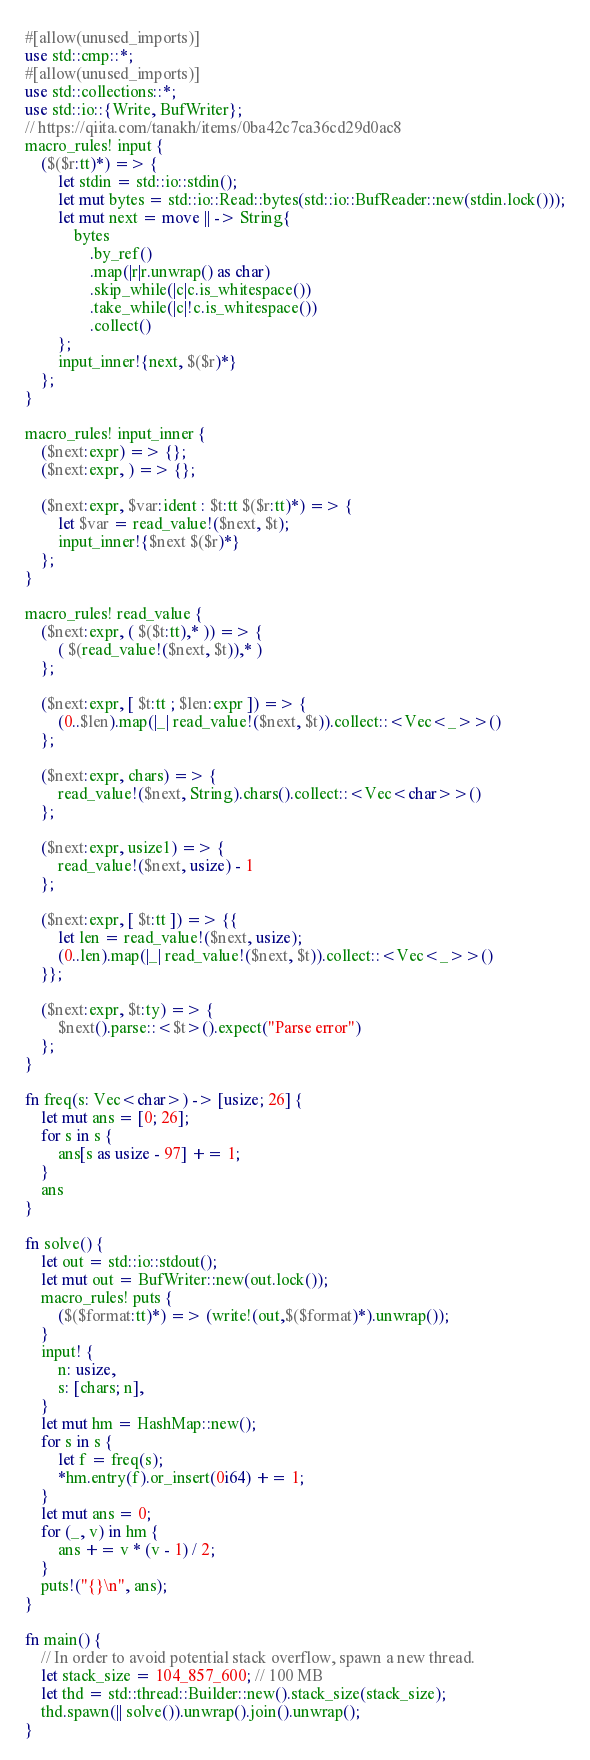Convert code to text. <code><loc_0><loc_0><loc_500><loc_500><_Rust_>#[allow(unused_imports)]
use std::cmp::*;
#[allow(unused_imports)]
use std::collections::*;
use std::io::{Write, BufWriter};
// https://qiita.com/tanakh/items/0ba42c7ca36cd29d0ac8
macro_rules! input {
    ($($r:tt)*) => {
        let stdin = std::io::stdin();
        let mut bytes = std::io::Read::bytes(std::io::BufReader::new(stdin.lock()));
        let mut next = move || -> String{
            bytes
                .by_ref()
                .map(|r|r.unwrap() as char)
                .skip_while(|c|c.is_whitespace())
                .take_while(|c|!c.is_whitespace())
                .collect()
        };
        input_inner!{next, $($r)*}
    };
}

macro_rules! input_inner {
    ($next:expr) => {};
    ($next:expr, ) => {};

    ($next:expr, $var:ident : $t:tt $($r:tt)*) => {
        let $var = read_value!($next, $t);
        input_inner!{$next $($r)*}
    };
}

macro_rules! read_value {
    ($next:expr, ( $($t:tt),* )) => {
        ( $(read_value!($next, $t)),* )
    };

    ($next:expr, [ $t:tt ; $len:expr ]) => {
        (0..$len).map(|_| read_value!($next, $t)).collect::<Vec<_>>()
    };

    ($next:expr, chars) => {
        read_value!($next, String).chars().collect::<Vec<char>>()
    };

    ($next:expr, usize1) => {
        read_value!($next, usize) - 1
    };

    ($next:expr, [ $t:tt ]) => {{
        let len = read_value!($next, usize);
        (0..len).map(|_| read_value!($next, $t)).collect::<Vec<_>>()
    }};

    ($next:expr, $t:ty) => {
        $next().parse::<$t>().expect("Parse error")
    };
}

fn freq(s: Vec<char>) -> [usize; 26] {
    let mut ans = [0; 26];
    for s in s {
        ans[s as usize - 97] += 1;
    }
    ans
}

fn solve() {
    let out = std::io::stdout();
    let mut out = BufWriter::new(out.lock());
    macro_rules! puts {
        ($($format:tt)*) => (write!(out,$($format)*).unwrap());
    }
    input! {
        n: usize,
        s: [chars; n],
    }
    let mut hm = HashMap::new();
    for s in s {
        let f = freq(s);
        *hm.entry(f).or_insert(0i64) += 1;
    }
    let mut ans = 0;
    for (_, v) in hm {
        ans += v * (v - 1) / 2;
    }
    puts!("{}\n", ans);
}

fn main() {
    // In order to avoid potential stack overflow, spawn a new thread.
    let stack_size = 104_857_600; // 100 MB
    let thd = std::thread::Builder::new().stack_size(stack_size);
    thd.spawn(|| solve()).unwrap().join().unwrap();
}
</code> 